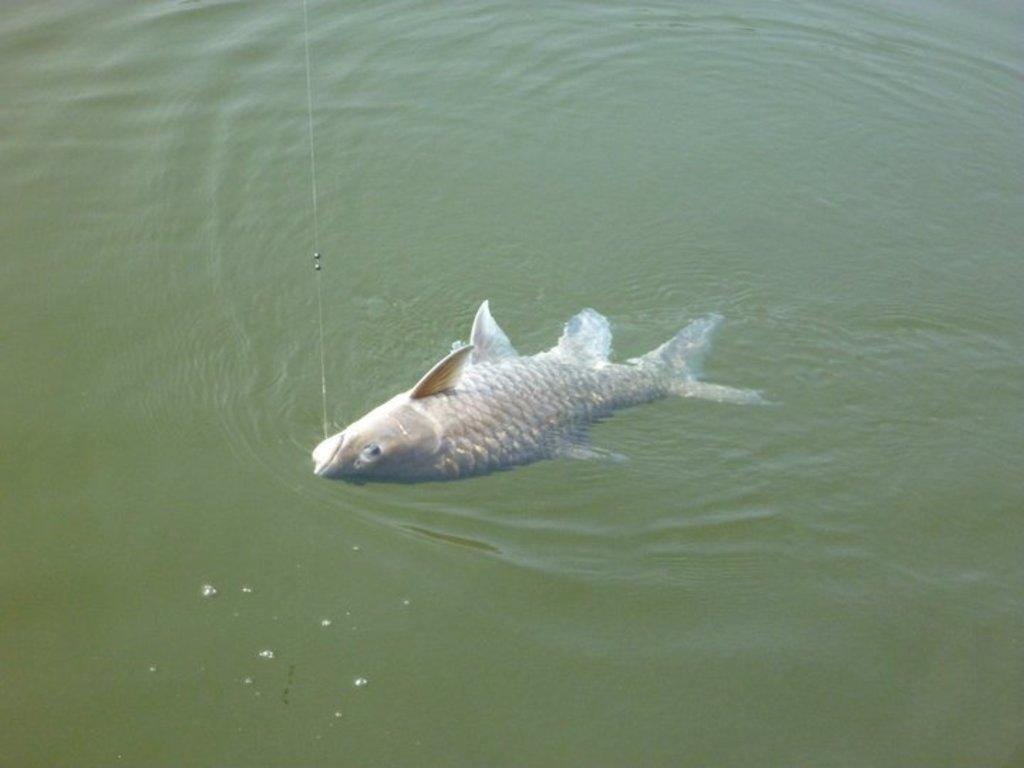What type of animal is in the image? There is a fish in the image. How is the fish being held or caught? The fish is caught by a hook. Where is the fish located in the image? The fish is in the water. What type of ray is used to cook the fish in the image? There is no ray or cooking activity present in the image; it only shows a fish caught by a hook in the water. 